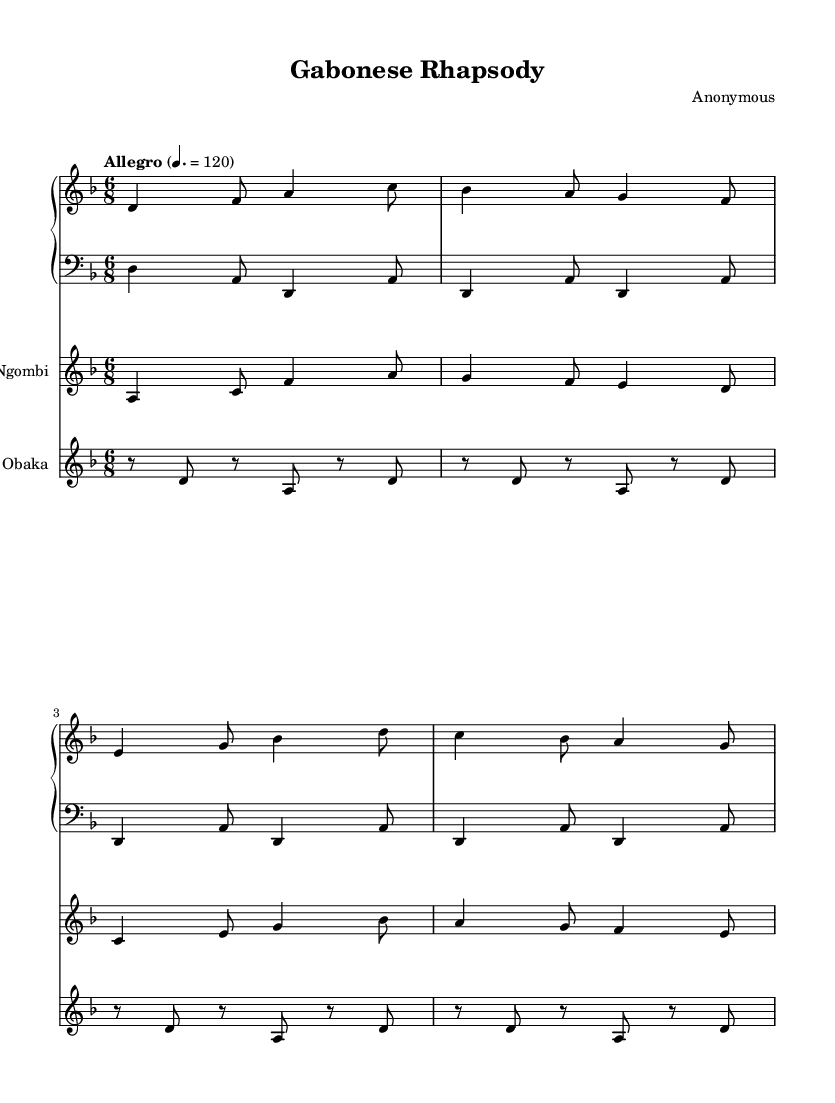What is the key signature of this music? The key signature is indicated at the beginning of the staff. The presence of one flat signifies that the key is D minor.
Answer: D minor What is the time signature of this music? The time signature is found to the left of the key signature at the beginning of the staff, which shows a 6 over 8, indicating it is in 6/8 time.
Answer: 6/8 What is the tempo marking for this piece? The tempo marking appears above the staff, indicating the speed at which the piece should be played, which is marked as "Allegro" with a metronome marking of quarter note equals 120.
Answer: Allegro 120 How many bars are present in the first section of the piano part? The piano part shows a total of four bars in the initial sequence, as each set of notes is grouped together with a vertical bar line.
Answer: 4 bars What instruments are represented in this piece? The sheet music includes parts for piano, ngombi, and obaka, which are indicated by the names above each staff in the score.
Answer: Piano, Ngombi, Obaka How many beats are there in each measure? The time signature of 6/8 indicates that each measure contains six eighth notes, which translates to six beats per measure.
Answer: 6 beats What is the highest note in the ngombi part? Looking at the ngombi staff, the highest note is A, which can be identified from the notational representation above the staff.
Answer: A 